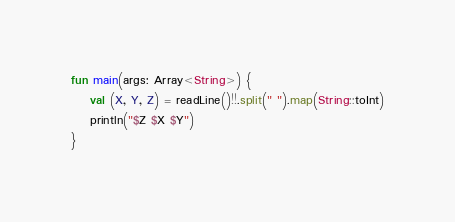Convert code to text. <code><loc_0><loc_0><loc_500><loc_500><_Kotlin_>fun main(args: Array<String>) {
    val (X, Y, Z) = readLine()!!.split(" ").map(String::toInt)
    println("$Z $X $Y")
}</code> 